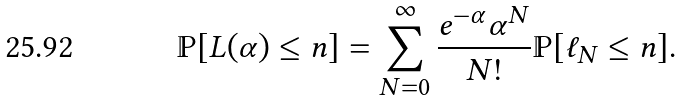<formula> <loc_0><loc_0><loc_500><loc_500>\mathbb { P } [ L ( \alpha ) \leq n ] = \sum _ { N = 0 } ^ { \infty } \frac { e ^ { - \alpha } \alpha ^ { N } } { N ! } \mathbb { P } [ \ell _ { N } \leq n ] .</formula> 